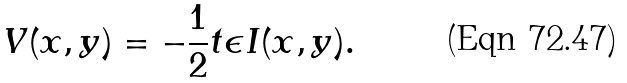Convert formula to latex. <formula><loc_0><loc_0><loc_500><loc_500>V ( x , y ) = - \frac { 1 } { 2 } t \epsilon I ( x , y ) .</formula> 